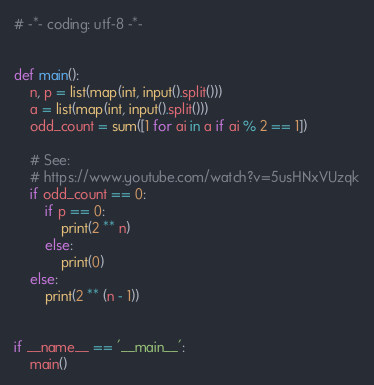Convert code to text. <code><loc_0><loc_0><loc_500><loc_500><_Python_># -*- coding: utf-8 -*-


def main():
    n, p = list(map(int, input().split()))
    a = list(map(int, input().split()))
    odd_count = sum([1 for ai in a if ai % 2 == 1])

    # See:
    # https://www.youtube.com/watch?v=5usHNxVUzqk
    if odd_count == 0:
        if p == 0:
            print(2 ** n)
        else:
            print(0)
    else:
        print(2 ** (n - 1))


if __name__ == '__main__':
    main()
</code> 